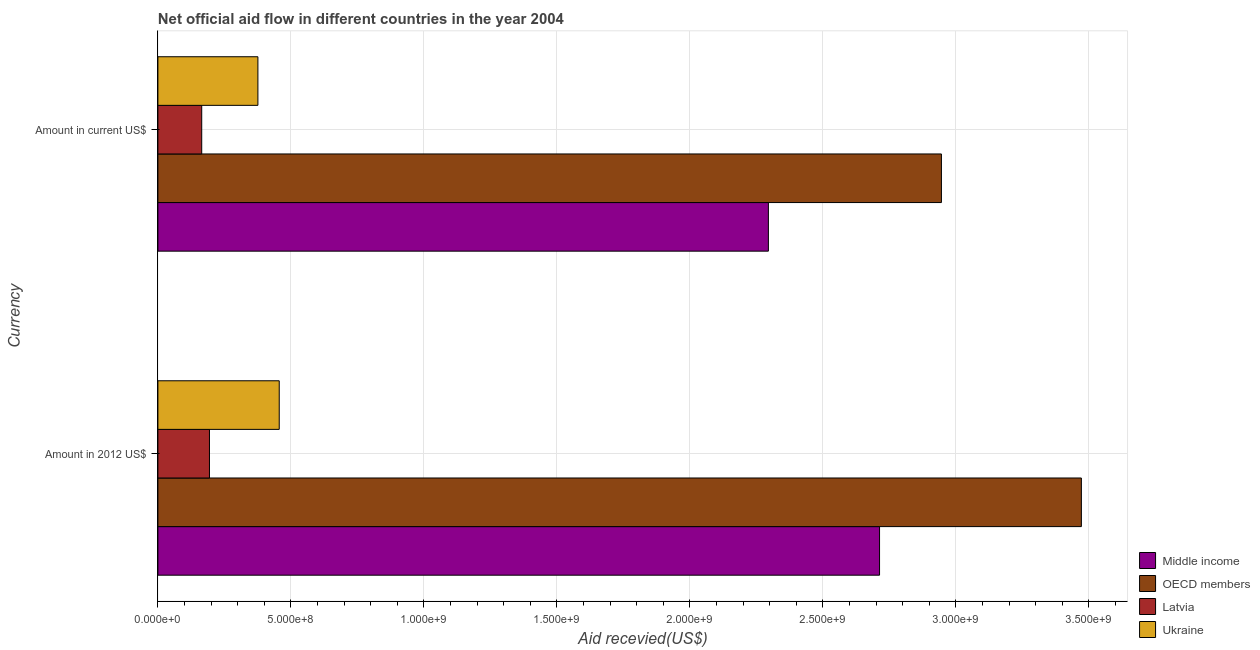How many different coloured bars are there?
Offer a very short reply. 4. Are the number of bars on each tick of the Y-axis equal?
Your answer should be compact. Yes. How many bars are there on the 1st tick from the top?
Make the answer very short. 4. What is the label of the 2nd group of bars from the top?
Offer a terse response. Amount in 2012 US$. What is the amount of aid received(expressed in 2012 us$) in Ukraine?
Offer a terse response. 4.56e+08. Across all countries, what is the maximum amount of aid received(expressed in 2012 us$)?
Your answer should be compact. 3.47e+09. Across all countries, what is the minimum amount of aid received(expressed in us$)?
Offer a very short reply. 1.65e+08. In which country was the amount of aid received(expressed in 2012 us$) minimum?
Ensure brevity in your answer.  Latvia. What is the total amount of aid received(expressed in us$) in the graph?
Your answer should be very brief. 5.78e+09. What is the difference between the amount of aid received(expressed in us$) in OECD members and that in Ukraine?
Offer a very short reply. 2.57e+09. What is the difference between the amount of aid received(expressed in 2012 us$) in Middle income and the amount of aid received(expressed in us$) in Ukraine?
Offer a terse response. 2.34e+09. What is the average amount of aid received(expressed in 2012 us$) per country?
Make the answer very short. 1.71e+09. What is the difference between the amount of aid received(expressed in us$) and amount of aid received(expressed in 2012 us$) in OECD members?
Your answer should be very brief. -5.26e+08. In how many countries, is the amount of aid received(expressed in us$) greater than 600000000 US$?
Keep it short and to the point. 2. What is the ratio of the amount of aid received(expressed in 2012 us$) in Middle income to that in Ukraine?
Ensure brevity in your answer.  5.95. What does the 2nd bar from the top in Amount in current US$ represents?
Make the answer very short. Latvia. What does the 2nd bar from the bottom in Amount in 2012 US$ represents?
Keep it short and to the point. OECD members. How many bars are there?
Give a very brief answer. 8. Are all the bars in the graph horizontal?
Your response must be concise. Yes. How many countries are there in the graph?
Offer a terse response. 4. How many legend labels are there?
Your answer should be compact. 4. What is the title of the graph?
Keep it short and to the point. Net official aid flow in different countries in the year 2004. Does "High income: nonOECD" appear as one of the legend labels in the graph?
Provide a succinct answer. No. What is the label or title of the X-axis?
Provide a short and direct response. Aid recevied(US$). What is the label or title of the Y-axis?
Give a very brief answer. Currency. What is the Aid recevied(US$) of Middle income in Amount in 2012 US$?
Your answer should be very brief. 2.71e+09. What is the Aid recevied(US$) in OECD members in Amount in 2012 US$?
Your answer should be compact. 3.47e+09. What is the Aid recevied(US$) in Latvia in Amount in 2012 US$?
Provide a succinct answer. 1.94e+08. What is the Aid recevied(US$) in Ukraine in Amount in 2012 US$?
Your response must be concise. 4.56e+08. What is the Aid recevied(US$) in Middle income in Amount in current US$?
Make the answer very short. 2.30e+09. What is the Aid recevied(US$) of OECD members in Amount in current US$?
Keep it short and to the point. 2.95e+09. What is the Aid recevied(US$) of Latvia in Amount in current US$?
Ensure brevity in your answer.  1.65e+08. What is the Aid recevied(US$) of Ukraine in Amount in current US$?
Your answer should be compact. 3.76e+08. Across all Currency, what is the maximum Aid recevied(US$) in Middle income?
Your answer should be compact. 2.71e+09. Across all Currency, what is the maximum Aid recevied(US$) in OECD members?
Make the answer very short. 3.47e+09. Across all Currency, what is the maximum Aid recevied(US$) in Latvia?
Your answer should be very brief. 1.94e+08. Across all Currency, what is the maximum Aid recevied(US$) of Ukraine?
Your response must be concise. 4.56e+08. Across all Currency, what is the minimum Aid recevied(US$) of Middle income?
Your answer should be compact. 2.30e+09. Across all Currency, what is the minimum Aid recevied(US$) in OECD members?
Provide a short and direct response. 2.95e+09. Across all Currency, what is the minimum Aid recevied(US$) in Latvia?
Your response must be concise. 1.65e+08. Across all Currency, what is the minimum Aid recevied(US$) of Ukraine?
Ensure brevity in your answer.  3.76e+08. What is the total Aid recevied(US$) of Middle income in the graph?
Your response must be concise. 5.01e+09. What is the total Aid recevied(US$) of OECD members in the graph?
Ensure brevity in your answer.  6.42e+09. What is the total Aid recevied(US$) in Latvia in the graph?
Give a very brief answer. 3.59e+08. What is the total Aid recevied(US$) in Ukraine in the graph?
Your answer should be compact. 8.32e+08. What is the difference between the Aid recevied(US$) in Middle income in Amount in 2012 US$ and that in Amount in current US$?
Offer a terse response. 4.18e+08. What is the difference between the Aid recevied(US$) of OECD members in Amount in 2012 US$ and that in Amount in current US$?
Make the answer very short. 5.26e+08. What is the difference between the Aid recevied(US$) in Latvia in Amount in 2012 US$ and that in Amount in current US$?
Your answer should be very brief. 2.91e+07. What is the difference between the Aid recevied(US$) in Ukraine in Amount in 2012 US$ and that in Amount in current US$?
Offer a terse response. 8.02e+07. What is the difference between the Aid recevied(US$) of Middle income in Amount in 2012 US$ and the Aid recevied(US$) of OECD members in Amount in current US$?
Ensure brevity in your answer.  -2.33e+08. What is the difference between the Aid recevied(US$) in Middle income in Amount in 2012 US$ and the Aid recevied(US$) in Latvia in Amount in current US$?
Ensure brevity in your answer.  2.55e+09. What is the difference between the Aid recevied(US$) of Middle income in Amount in 2012 US$ and the Aid recevied(US$) of Ukraine in Amount in current US$?
Offer a terse response. 2.34e+09. What is the difference between the Aid recevied(US$) in OECD members in Amount in 2012 US$ and the Aid recevied(US$) in Latvia in Amount in current US$?
Ensure brevity in your answer.  3.31e+09. What is the difference between the Aid recevied(US$) in OECD members in Amount in 2012 US$ and the Aid recevied(US$) in Ukraine in Amount in current US$?
Make the answer very short. 3.10e+09. What is the difference between the Aid recevied(US$) in Latvia in Amount in 2012 US$ and the Aid recevied(US$) in Ukraine in Amount in current US$?
Offer a very short reply. -1.82e+08. What is the average Aid recevied(US$) in Middle income per Currency?
Your answer should be very brief. 2.50e+09. What is the average Aid recevied(US$) in OECD members per Currency?
Provide a succinct answer. 3.21e+09. What is the average Aid recevied(US$) of Latvia per Currency?
Your answer should be very brief. 1.79e+08. What is the average Aid recevied(US$) of Ukraine per Currency?
Give a very brief answer. 4.16e+08. What is the difference between the Aid recevied(US$) of Middle income and Aid recevied(US$) of OECD members in Amount in 2012 US$?
Ensure brevity in your answer.  -7.59e+08. What is the difference between the Aid recevied(US$) in Middle income and Aid recevied(US$) in Latvia in Amount in 2012 US$?
Keep it short and to the point. 2.52e+09. What is the difference between the Aid recevied(US$) of Middle income and Aid recevied(US$) of Ukraine in Amount in 2012 US$?
Your response must be concise. 2.26e+09. What is the difference between the Aid recevied(US$) in OECD members and Aid recevied(US$) in Latvia in Amount in 2012 US$?
Ensure brevity in your answer.  3.28e+09. What is the difference between the Aid recevied(US$) in OECD members and Aid recevied(US$) in Ukraine in Amount in 2012 US$?
Make the answer very short. 3.02e+09. What is the difference between the Aid recevied(US$) in Latvia and Aid recevied(US$) in Ukraine in Amount in 2012 US$?
Your answer should be very brief. -2.62e+08. What is the difference between the Aid recevied(US$) of Middle income and Aid recevied(US$) of OECD members in Amount in current US$?
Provide a succinct answer. -6.51e+08. What is the difference between the Aid recevied(US$) of Middle income and Aid recevied(US$) of Latvia in Amount in current US$?
Ensure brevity in your answer.  2.13e+09. What is the difference between the Aid recevied(US$) of Middle income and Aid recevied(US$) of Ukraine in Amount in current US$?
Offer a terse response. 1.92e+09. What is the difference between the Aid recevied(US$) in OECD members and Aid recevied(US$) in Latvia in Amount in current US$?
Offer a very short reply. 2.78e+09. What is the difference between the Aid recevied(US$) of OECD members and Aid recevied(US$) of Ukraine in Amount in current US$?
Provide a short and direct response. 2.57e+09. What is the difference between the Aid recevied(US$) of Latvia and Aid recevied(US$) of Ukraine in Amount in current US$?
Provide a succinct answer. -2.11e+08. What is the ratio of the Aid recevied(US$) in Middle income in Amount in 2012 US$ to that in Amount in current US$?
Make the answer very short. 1.18. What is the ratio of the Aid recevied(US$) of OECD members in Amount in 2012 US$ to that in Amount in current US$?
Provide a short and direct response. 1.18. What is the ratio of the Aid recevied(US$) of Latvia in Amount in 2012 US$ to that in Amount in current US$?
Provide a succinct answer. 1.18. What is the ratio of the Aid recevied(US$) in Ukraine in Amount in 2012 US$ to that in Amount in current US$?
Offer a very short reply. 1.21. What is the difference between the highest and the second highest Aid recevied(US$) of Middle income?
Make the answer very short. 4.18e+08. What is the difference between the highest and the second highest Aid recevied(US$) in OECD members?
Keep it short and to the point. 5.26e+08. What is the difference between the highest and the second highest Aid recevied(US$) in Latvia?
Your answer should be compact. 2.91e+07. What is the difference between the highest and the second highest Aid recevied(US$) of Ukraine?
Give a very brief answer. 8.02e+07. What is the difference between the highest and the lowest Aid recevied(US$) in Middle income?
Your answer should be very brief. 4.18e+08. What is the difference between the highest and the lowest Aid recevied(US$) of OECD members?
Your answer should be compact. 5.26e+08. What is the difference between the highest and the lowest Aid recevied(US$) of Latvia?
Make the answer very short. 2.91e+07. What is the difference between the highest and the lowest Aid recevied(US$) in Ukraine?
Give a very brief answer. 8.02e+07. 